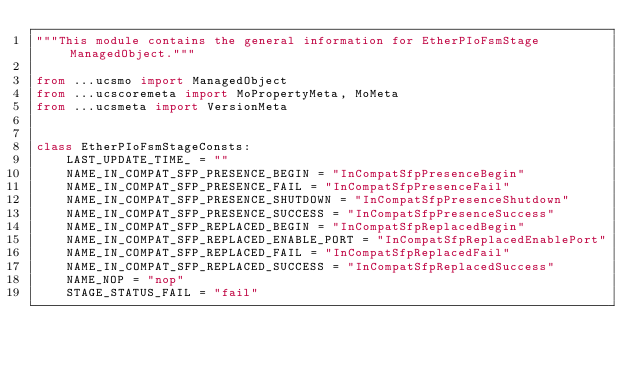<code> <loc_0><loc_0><loc_500><loc_500><_Python_>"""This module contains the general information for EtherPIoFsmStage ManagedObject."""

from ...ucsmo import ManagedObject
from ...ucscoremeta import MoPropertyMeta, MoMeta
from ...ucsmeta import VersionMeta


class EtherPIoFsmStageConsts:
    LAST_UPDATE_TIME_ = ""
    NAME_IN_COMPAT_SFP_PRESENCE_BEGIN = "InCompatSfpPresenceBegin"
    NAME_IN_COMPAT_SFP_PRESENCE_FAIL = "InCompatSfpPresenceFail"
    NAME_IN_COMPAT_SFP_PRESENCE_SHUTDOWN = "InCompatSfpPresenceShutdown"
    NAME_IN_COMPAT_SFP_PRESENCE_SUCCESS = "InCompatSfpPresenceSuccess"
    NAME_IN_COMPAT_SFP_REPLACED_BEGIN = "InCompatSfpReplacedBegin"
    NAME_IN_COMPAT_SFP_REPLACED_ENABLE_PORT = "InCompatSfpReplacedEnablePort"
    NAME_IN_COMPAT_SFP_REPLACED_FAIL = "InCompatSfpReplacedFail"
    NAME_IN_COMPAT_SFP_REPLACED_SUCCESS = "InCompatSfpReplacedSuccess"
    NAME_NOP = "nop"
    STAGE_STATUS_FAIL = "fail"</code> 